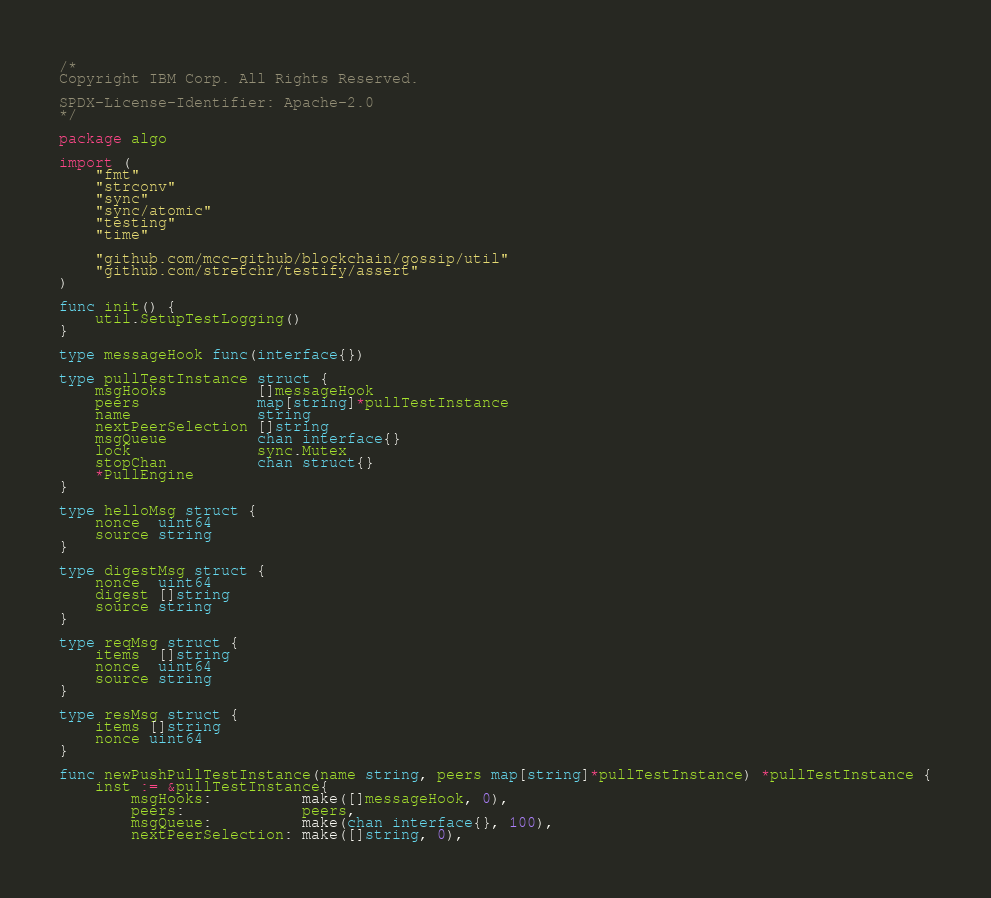Convert code to text. <code><loc_0><loc_0><loc_500><loc_500><_Go_>/*
Copyright IBM Corp. All Rights Reserved.

SPDX-License-Identifier: Apache-2.0
*/

package algo

import (
	"fmt"
	"strconv"
	"sync"
	"sync/atomic"
	"testing"
	"time"

	"github.com/mcc-github/blockchain/gossip/util"
	"github.com/stretchr/testify/assert"
)

func init() {
	util.SetupTestLogging()
}

type messageHook func(interface{})

type pullTestInstance struct {
	msgHooks          []messageHook
	peers             map[string]*pullTestInstance
	name              string
	nextPeerSelection []string
	msgQueue          chan interface{}
	lock              sync.Mutex
	stopChan          chan struct{}
	*PullEngine
}

type helloMsg struct {
	nonce  uint64
	source string
}

type digestMsg struct {
	nonce  uint64
	digest []string
	source string
}

type reqMsg struct {
	items  []string
	nonce  uint64
	source string
}

type resMsg struct {
	items []string
	nonce uint64
}

func newPushPullTestInstance(name string, peers map[string]*pullTestInstance) *pullTestInstance {
	inst := &pullTestInstance{
		msgHooks:          make([]messageHook, 0),
		peers:             peers,
		msgQueue:          make(chan interface{}, 100),
		nextPeerSelection: make([]string, 0),</code> 